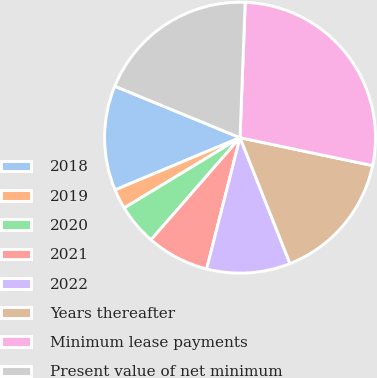Convert chart to OTSL. <chart><loc_0><loc_0><loc_500><loc_500><pie_chart><fcel>2018<fcel>2019<fcel>2020<fcel>2021<fcel>2022<fcel>Years thereafter<fcel>Minimum lease payments<fcel>Present value of net minimum<nl><fcel>12.51%<fcel>2.38%<fcel>4.91%<fcel>7.44%<fcel>9.98%<fcel>15.68%<fcel>27.7%<fcel>19.4%<nl></chart> 